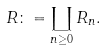Convert formula to latex. <formula><loc_0><loc_0><loc_500><loc_500>R \colon = \coprod _ { n \geq 0 } R _ { n } .</formula> 